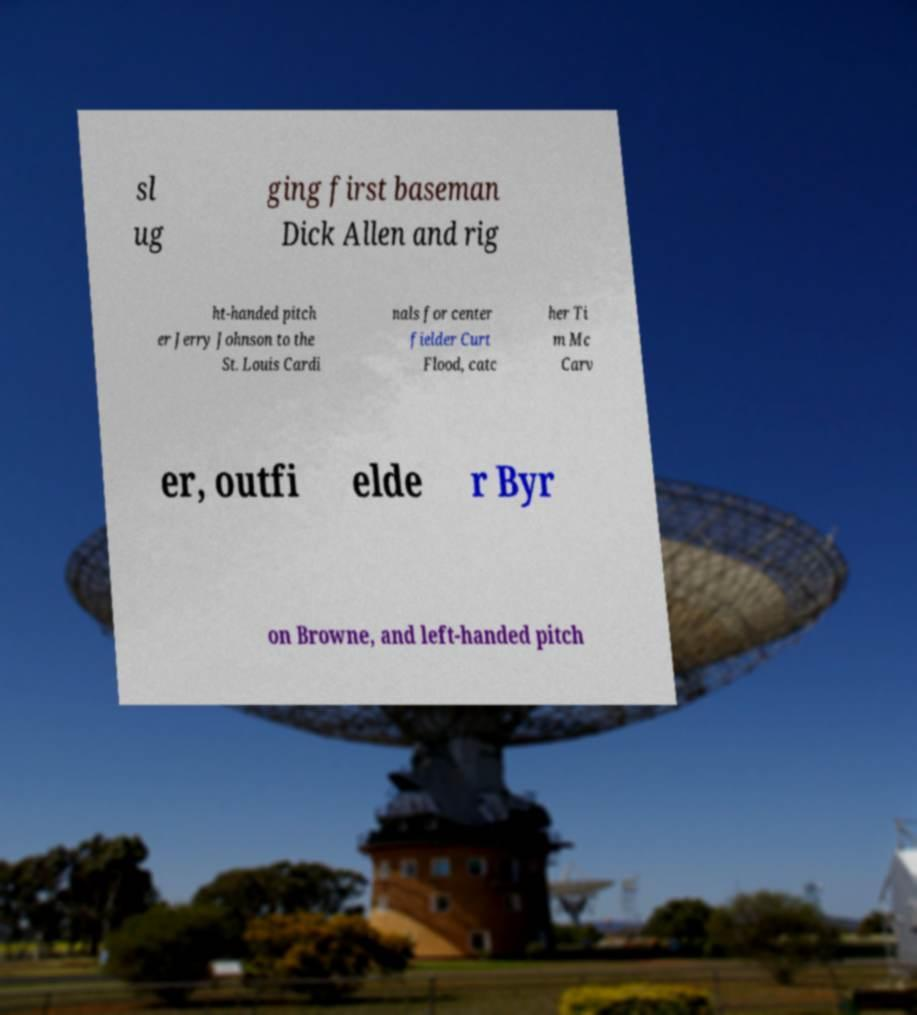Please identify and transcribe the text found in this image. sl ug ging first baseman Dick Allen and rig ht-handed pitch er Jerry Johnson to the St. Louis Cardi nals for center fielder Curt Flood, catc her Ti m Mc Carv er, outfi elde r Byr on Browne, and left-handed pitch 